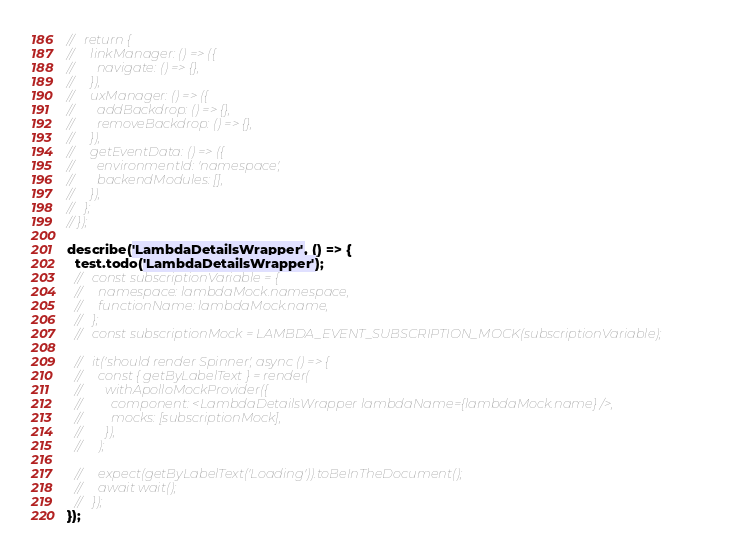Convert code to text. <code><loc_0><loc_0><loc_500><loc_500><_JavaScript_>//   return {
//     linkManager: () => ({
//       navigate: () => {},
//     }),
//     uxManager: () => ({
//       addBackdrop: () => {},
//       removeBackdrop: () => {},
//     }),
//     getEventData: () => ({
//       environmentId: 'namespace',
//       backendModules: [],
//     }),
//   };
// });

describe('LambdaDetailsWrapper', () => {
  test.todo('LambdaDetailsWrapper');
  //   const subscriptionVariable = {
  //     namespace: lambdaMock.namespace,
  //     functionName: lambdaMock.name,
  //   };
  //   const subscriptionMock = LAMBDA_EVENT_SUBSCRIPTION_MOCK(subscriptionVariable);

  //   it('should render Spinner', async () => {
  //     const { getByLabelText } = render(
  //       withApolloMockProvider({
  //         component: <LambdaDetailsWrapper lambdaName={lambdaMock.name} />,
  //         mocks: [subscriptionMock],
  //       }),
  //     );

  //     expect(getByLabelText('Loading')).toBeInTheDocument();
  //     await wait();
  //   });
});
</code> 